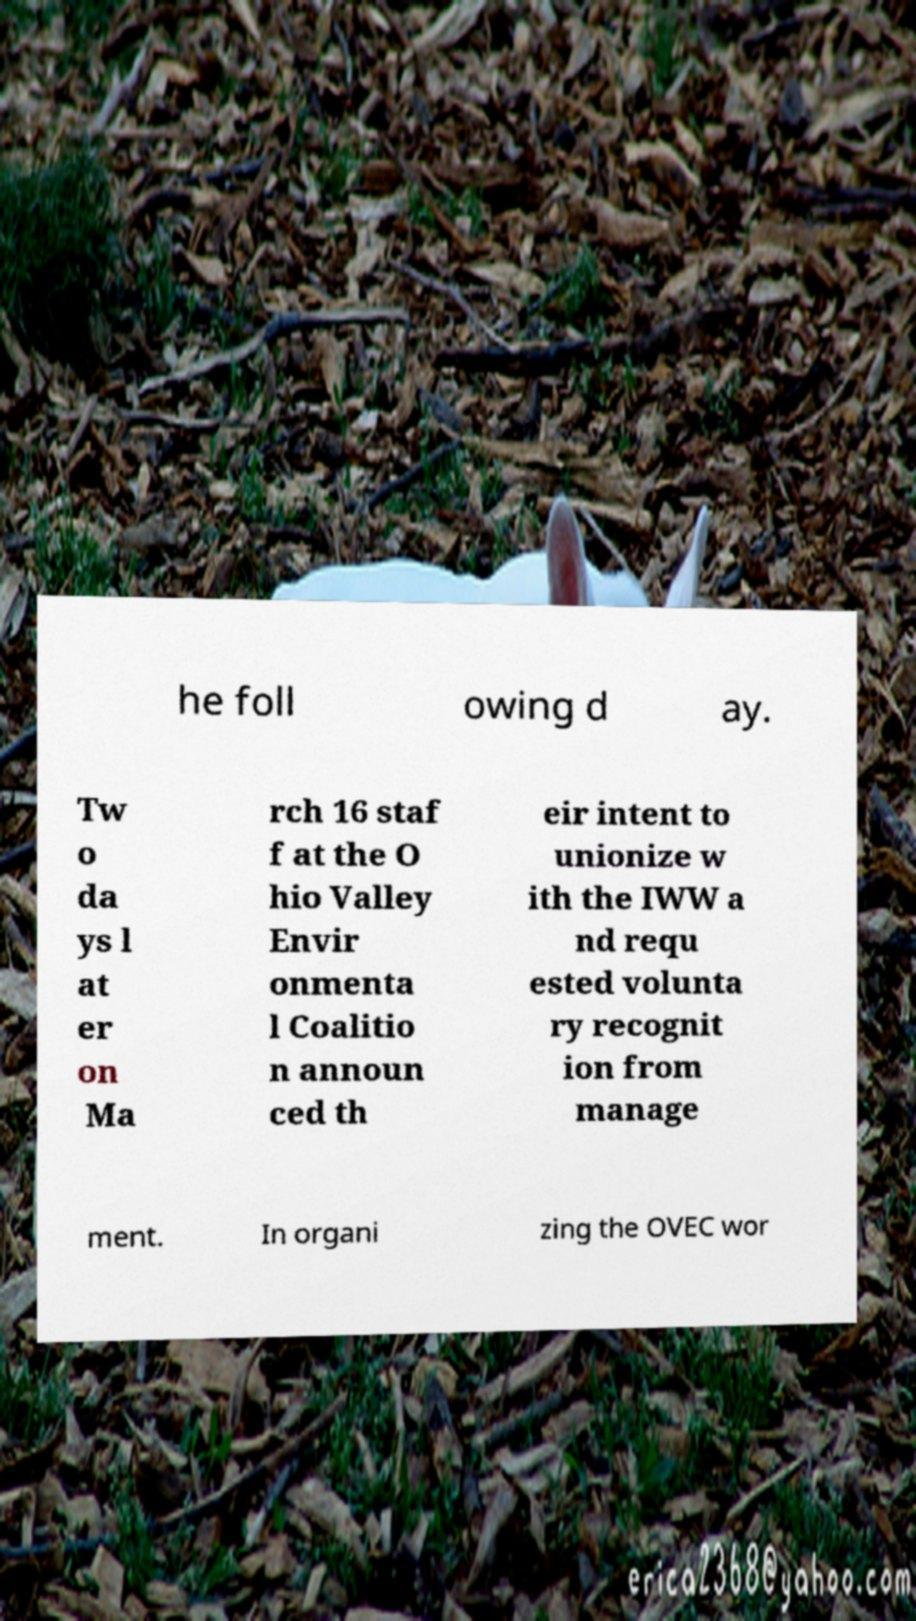Please read and relay the text visible in this image. What does it say? he foll owing d ay. Tw o da ys l at er on Ma rch 16 staf f at the O hio Valley Envir onmenta l Coalitio n announ ced th eir intent to unionize w ith the IWW a nd requ ested volunta ry recognit ion from manage ment. In organi zing the OVEC wor 